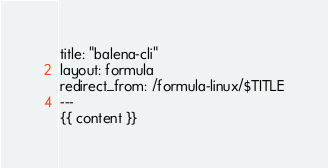Convert code to text. <code><loc_0><loc_0><loc_500><loc_500><_HTML_>title: "balena-cli"
layout: formula
redirect_from: /formula-linux/$TITLE
---
{{ content }}
</code> 